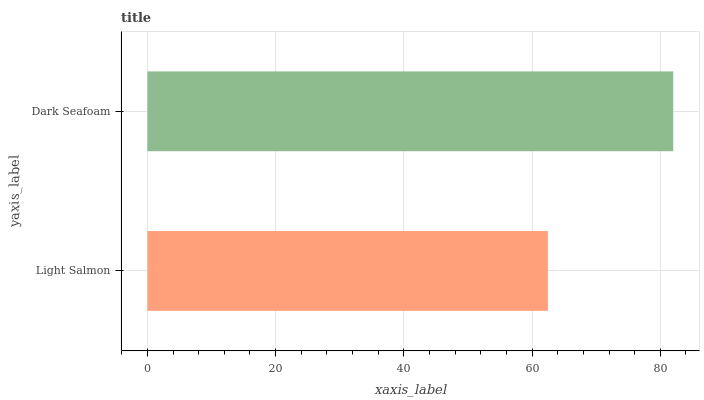Is Light Salmon the minimum?
Answer yes or no. Yes. Is Dark Seafoam the maximum?
Answer yes or no. Yes. Is Dark Seafoam the minimum?
Answer yes or no. No. Is Dark Seafoam greater than Light Salmon?
Answer yes or no. Yes. Is Light Salmon less than Dark Seafoam?
Answer yes or no. Yes. Is Light Salmon greater than Dark Seafoam?
Answer yes or no. No. Is Dark Seafoam less than Light Salmon?
Answer yes or no. No. Is Dark Seafoam the high median?
Answer yes or no. Yes. Is Light Salmon the low median?
Answer yes or no. Yes. Is Light Salmon the high median?
Answer yes or no. No. Is Dark Seafoam the low median?
Answer yes or no. No. 